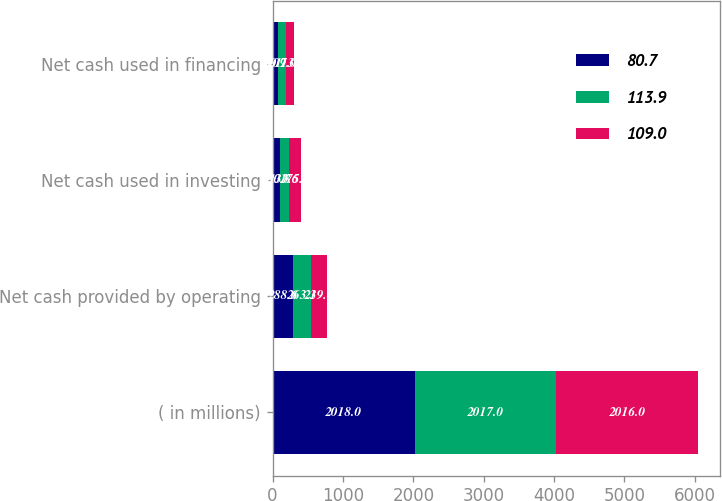Convert chart. <chart><loc_0><loc_0><loc_500><loc_500><stacked_bar_chart><ecel><fcel>( in millions)<fcel>Net cash provided by operating<fcel>Net cash used in investing<fcel>Net cash used in financing<nl><fcel>80.7<fcel>2018<fcel>288.6<fcel>100.8<fcel>80.7<nl><fcel>113.9<fcel>2017<fcel>263.3<fcel>133.6<fcel>109<nl><fcel>109<fcel>2016<fcel>219.4<fcel>175.8<fcel>113.9<nl></chart> 